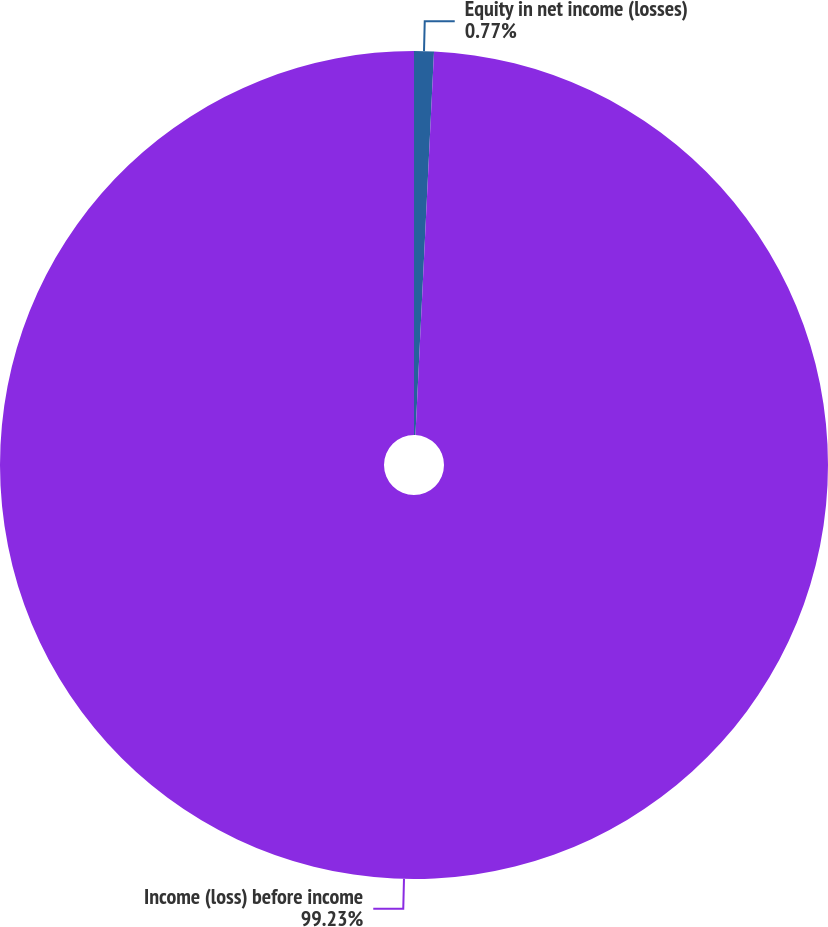<chart> <loc_0><loc_0><loc_500><loc_500><pie_chart><fcel>Equity in net income (losses)<fcel>Income (loss) before income<nl><fcel>0.77%<fcel>99.23%<nl></chart> 